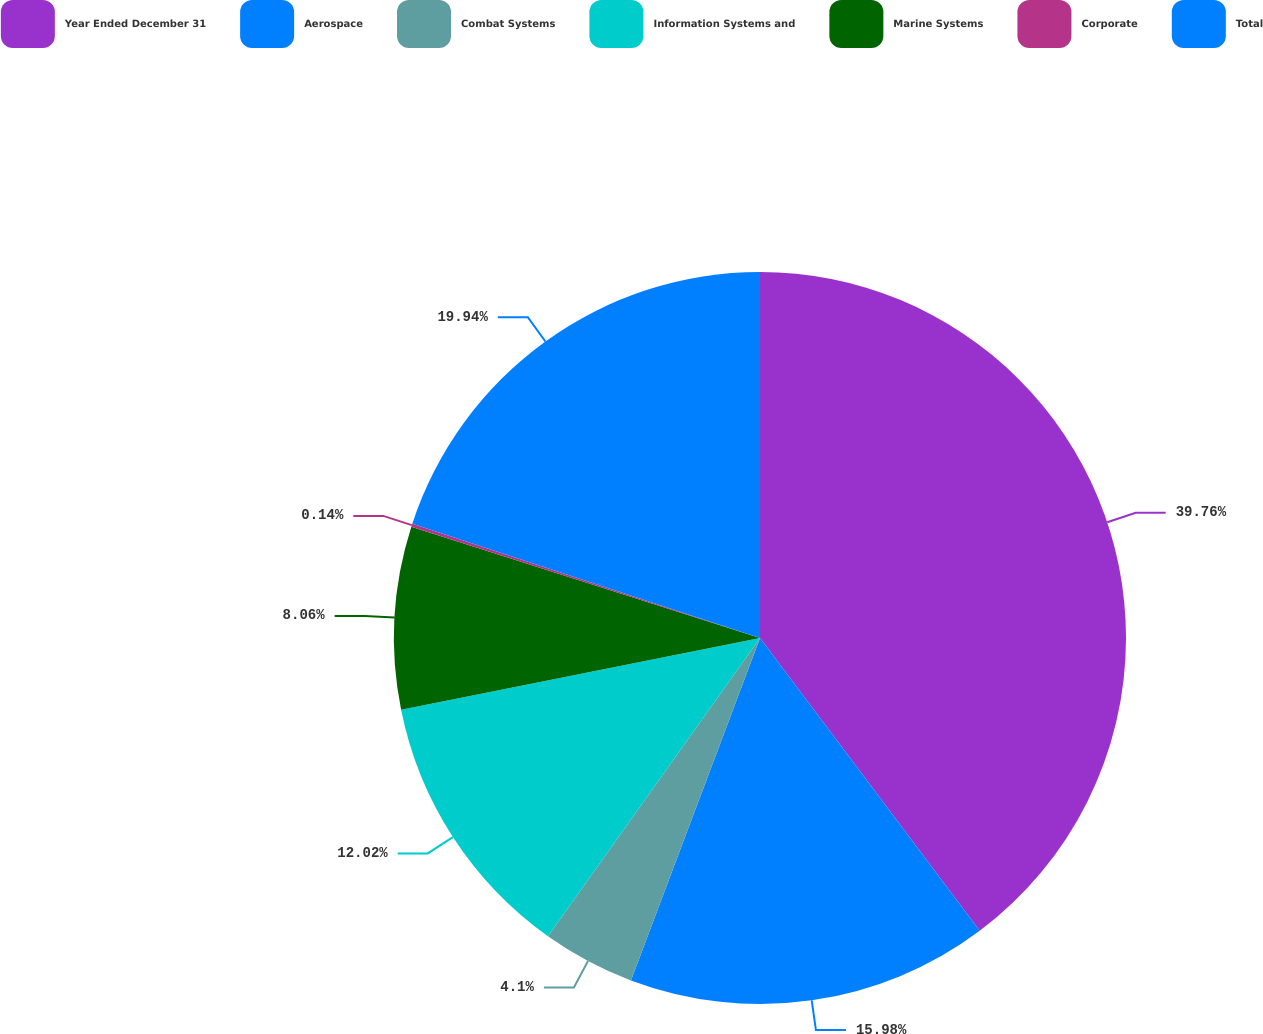Convert chart to OTSL. <chart><loc_0><loc_0><loc_500><loc_500><pie_chart><fcel>Year Ended December 31<fcel>Aerospace<fcel>Combat Systems<fcel>Information Systems and<fcel>Marine Systems<fcel>Corporate<fcel>Total<nl><fcel>39.75%<fcel>15.98%<fcel>4.1%<fcel>12.02%<fcel>8.06%<fcel>0.14%<fcel>19.94%<nl></chart> 